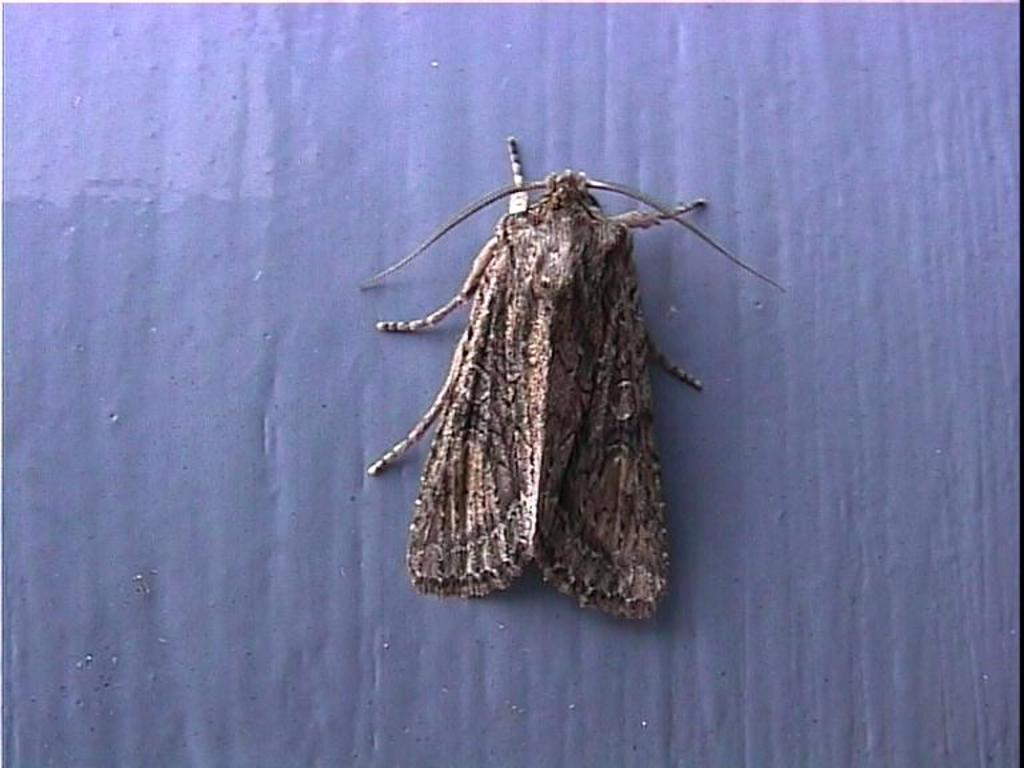What type of creature is present in the image? There is an insect in the image. What feature of the insect can be observed? The insect has wings. What type of apparel is the goat wearing in the image? There is no goat or apparel present in the image; it only features an insect with wings. 